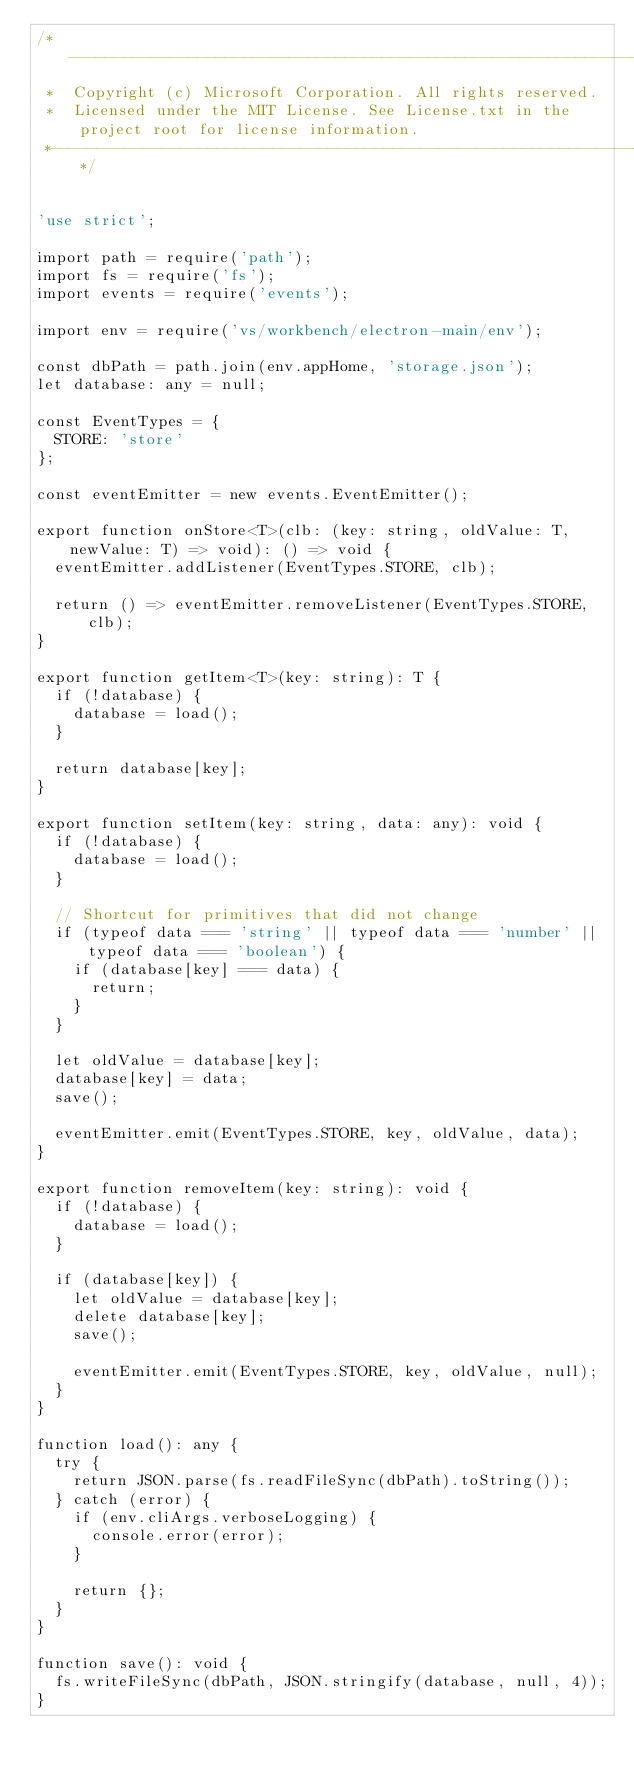Convert code to text. <code><loc_0><loc_0><loc_500><loc_500><_TypeScript_>/*---------------------------------------------------------------------------------------------
 *  Copyright (c) Microsoft Corporation. All rights reserved.
 *  Licensed under the MIT License. See License.txt in the project root for license information.
 *--------------------------------------------------------------------------------------------*/


'use strict';

import path = require('path');
import fs = require('fs');
import events = require('events');

import env = require('vs/workbench/electron-main/env');

const dbPath = path.join(env.appHome, 'storage.json');
let database: any = null;

const EventTypes = {
	STORE: 'store'
};

const eventEmitter = new events.EventEmitter();

export function onStore<T>(clb: (key: string, oldValue: T, newValue: T) => void): () => void {
	eventEmitter.addListener(EventTypes.STORE, clb);

	return () => eventEmitter.removeListener(EventTypes.STORE, clb);
}

export function getItem<T>(key: string): T {
	if (!database) {
		database = load();
	}

	return database[key];
}

export function setItem(key: string, data: any): void {
	if (!database) {
		database = load();
	}

	// Shortcut for primitives that did not change
	if (typeof data === 'string' || typeof data === 'number' || typeof data === 'boolean') {
		if (database[key] === data) {
			return;
		}
	}

	let oldValue = database[key];
	database[key] = data;
	save();

	eventEmitter.emit(EventTypes.STORE, key, oldValue, data);
}

export function removeItem(key: string): void {
	if (!database) {
		database = load();
	}

	if (database[key]) {
		let oldValue = database[key];
		delete database[key];
		save();

		eventEmitter.emit(EventTypes.STORE, key, oldValue, null);
	}
}

function load(): any {
	try {
		return JSON.parse(fs.readFileSync(dbPath).toString());
	} catch (error) {
		if (env.cliArgs.verboseLogging) {
			console.error(error);
		}

		return {};
	}
}

function save(): void {
	fs.writeFileSync(dbPath, JSON.stringify(database, null, 4));
}</code> 